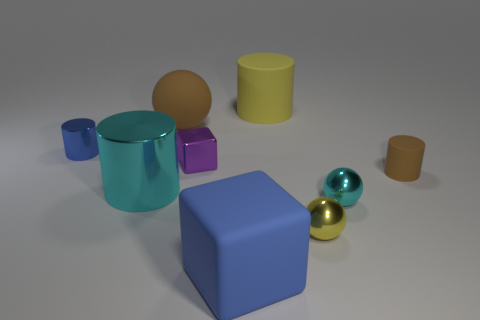What number of large metallic objects are the same color as the large metallic cylinder?
Your answer should be very brief. 0. There is a cyan sphere; does it have the same size as the brown thing right of the big ball?
Make the answer very short. Yes. The blue thing left of the blue object to the right of the tiny blue metallic cylinder is made of what material?
Your answer should be very brief. Metal. Are there an equal number of small yellow objects and green rubber things?
Give a very brief answer. No. There is a cylinder that is behind the brown sphere that is in front of the yellow object that is behind the small yellow shiny ball; what is its size?
Give a very brief answer. Large. There is a big blue thing; does it have the same shape as the brown rubber thing in front of the small blue cylinder?
Your response must be concise. No. What is the small yellow sphere made of?
Your answer should be compact. Metal. How many rubber objects are cyan balls or brown spheres?
Keep it short and to the point. 1. Is the number of cubes in front of the brown rubber ball less than the number of large brown spheres that are in front of the tiny metal cylinder?
Provide a short and direct response. No. There is a small cylinder that is on the left side of the rubber cylinder in front of the big yellow matte cylinder; are there any small brown matte cylinders that are to the left of it?
Offer a very short reply. No. 